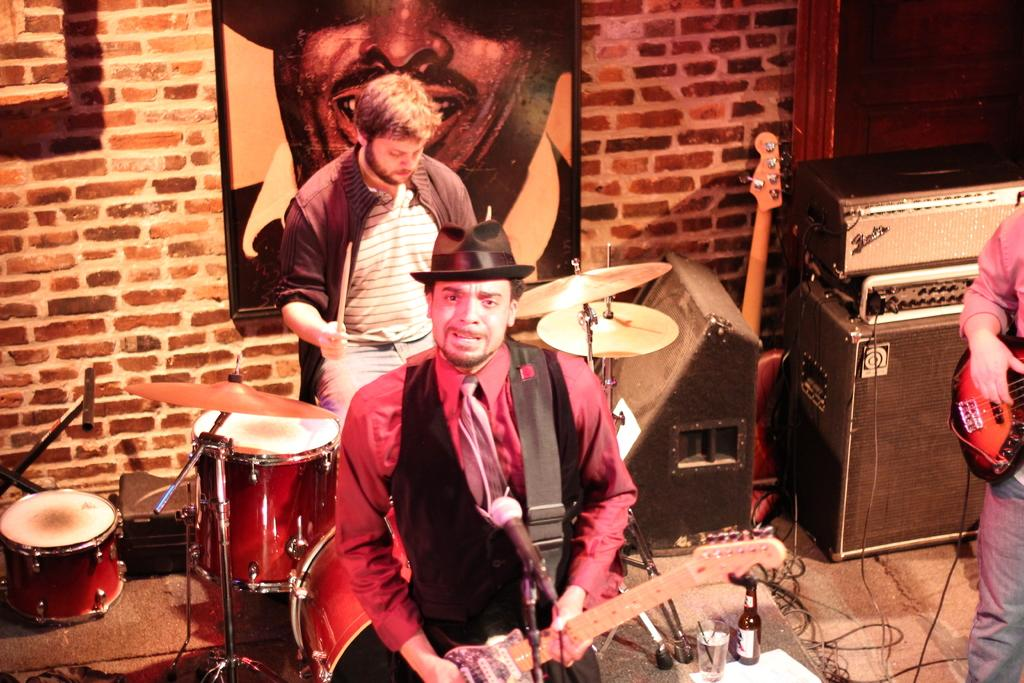What type of group is featured in the picture? There is a music band in the picture. What instruments are being played by the band members? Some members of the band are playing guitar, and there is a person in the background playing drums. Can you describe anything else visible in the image? There is a photograph attached to a wall in the image. Where is the heart-shaped cave located in the image? There is no heart-shaped cave present in the image. What type of animal can be seen playing with a cub in the image? There are no animals or cubs present in the image; it features a music band. 